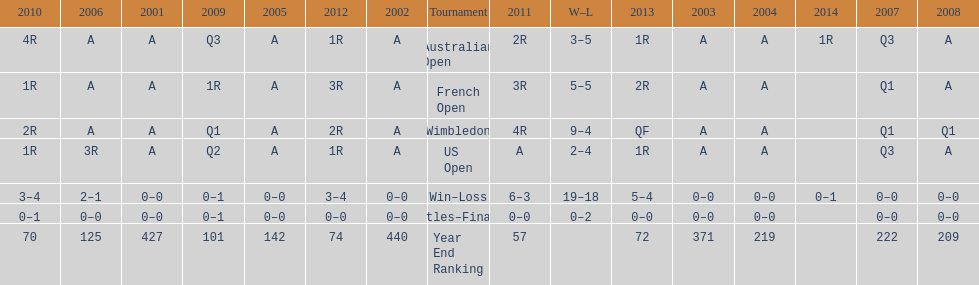What is the difference in wins between wimbledon and the us open for this player? 7. I'm looking to parse the entire table for insights. Could you assist me with that? {'header': ['2010', '2006', '2001', '2009', '2005', '2012', '2002', 'Tournament', '2011', 'W–L', '2013', '2003', '2004', '2014', '2007', '2008'], 'rows': [['4R', 'A', 'A', 'Q3', 'A', '1R', 'A', 'Australian Open', '2R', '3–5', '1R', 'A', 'A', '1R', 'Q3', 'A'], ['1R', 'A', 'A', '1R', 'A', '3R', 'A', 'French Open', '3R', '5–5', '2R', 'A', 'A', '', 'Q1', 'A'], ['2R', 'A', 'A', 'Q1', 'A', '2R', 'A', 'Wimbledon', '4R', '9–4', 'QF', 'A', 'A', '', 'Q1', 'Q1'], ['1R', '3R', 'A', 'Q2', 'A', '1R', 'A', 'US Open', 'A', '2–4', '1R', 'A', 'A', '', 'Q3', 'A'], ['3–4', '2–1', '0–0', '0–1', '0–0', '3–4', '0–0', 'Win–Loss', '6–3', '19–18', '5–4', '0–0', '0–0', '0–1', '0–0', '0–0'], ['0–1', '0–0', '0–0', '0–1', '0–0', '0–0', '0–0', 'Titles–Finals', '0–0', '0–2', '0–0', '0–0', '0–0', '', '0–0', '0–0'], ['70', '125', '427', '101', '142', '74', '440', 'Year End Ranking', '57', '', '72', '371', '219', '', '222', '209']]} 